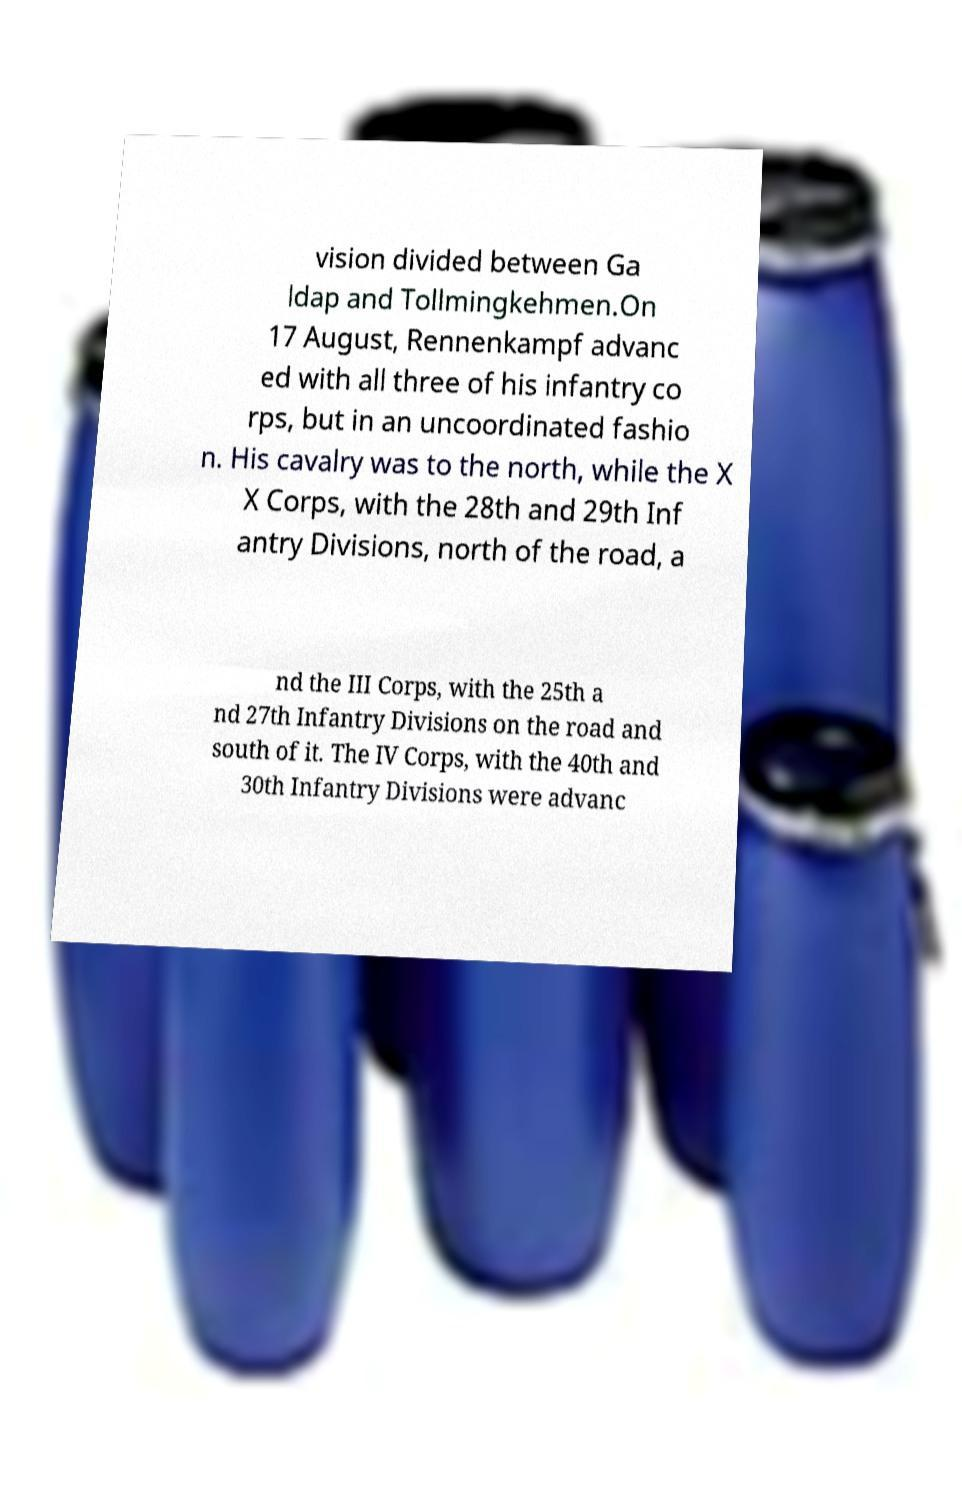For documentation purposes, I need the text within this image transcribed. Could you provide that? vision divided between Ga ldap and Tollmingkehmen.On 17 August, Rennenkampf advanc ed with all three of his infantry co rps, but in an uncoordinated fashio n. His cavalry was to the north, while the X X Corps, with the 28th and 29th Inf antry Divisions, north of the road, a nd the III Corps, with the 25th a nd 27th Infantry Divisions on the road and south of it. The IV Corps, with the 40th and 30th Infantry Divisions were advanc 